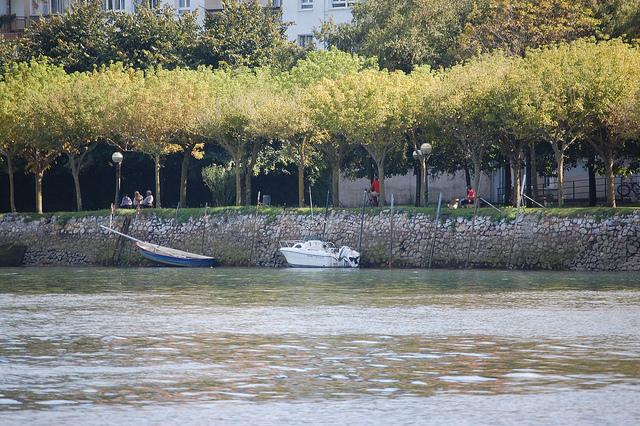Could you find this scene in Kansas?
Short answer required. Yes. What color are those trees?
Give a very brief answer. Green. Is the wall natural or man-made?
Keep it brief. Man made. 